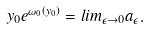<formula> <loc_0><loc_0><loc_500><loc_500>y _ { 0 } e ^ { \omega _ { 0 } ( y _ { 0 } ) } = l i m _ { \epsilon \to 0 } a _ { \epsilon } .</formula> 